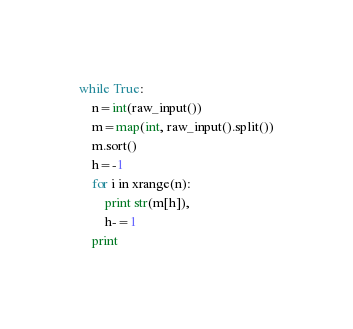<code> <loc_0><loc_0><loc_500><loc_500><_Python_>while True:
    n=int(raw_input())
    m=map(int, raw_input().split())
    m.sort()
    h=-1
    for i in xrange(n):
        print str(m[h]),
        h-=1
    print</code> 